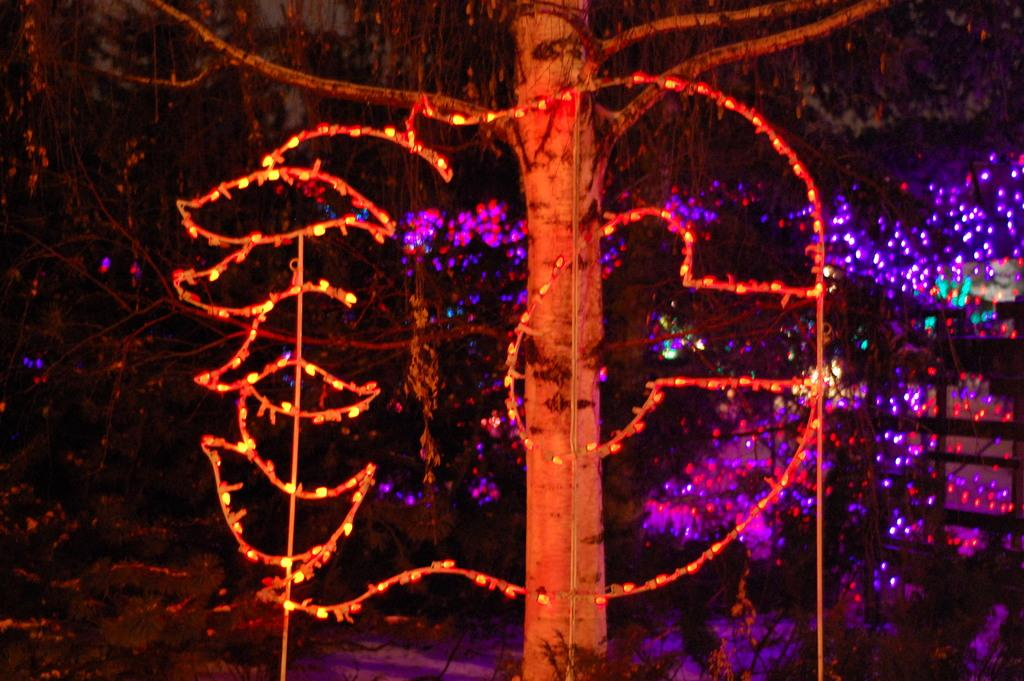What type of natural elements can be seen in the image? There are trees in the image. What additional features are present in the image? Decorative lights are visible in the image. What type of stick can be seen in the image? There is no stick present in the image. How much milk is being consumed in the image? There is no milk or consumption of milk depicted in the image. 